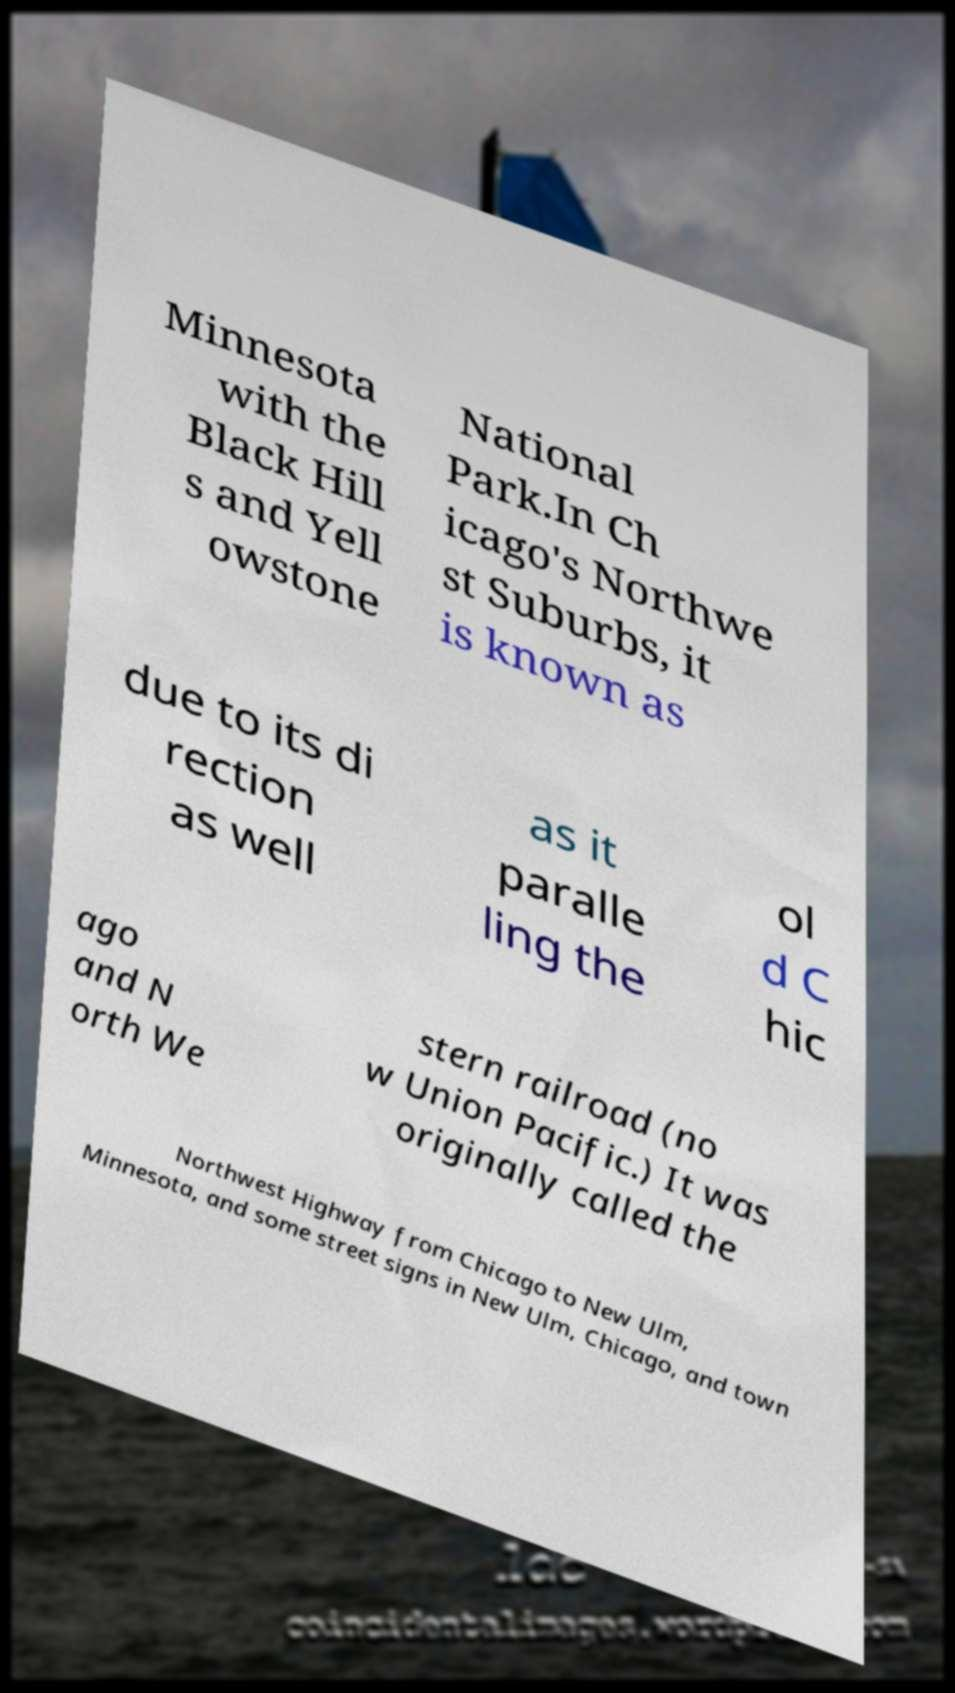Please read and relay the text visible in this image. What does it say? Minnesota with the Black Hill s and Yell owstone National Park.In Ch icago's Northwe st Suburbs, it is known as due to its di rection as well as it paralle ling the ol d C hic ago and N orth We stern railroad (no w Union Pacific.) It was originally called the Northwest Highway from Chicago to New Ulm, Minnesota, and some street signs in New Ulm, Chicago, and town 